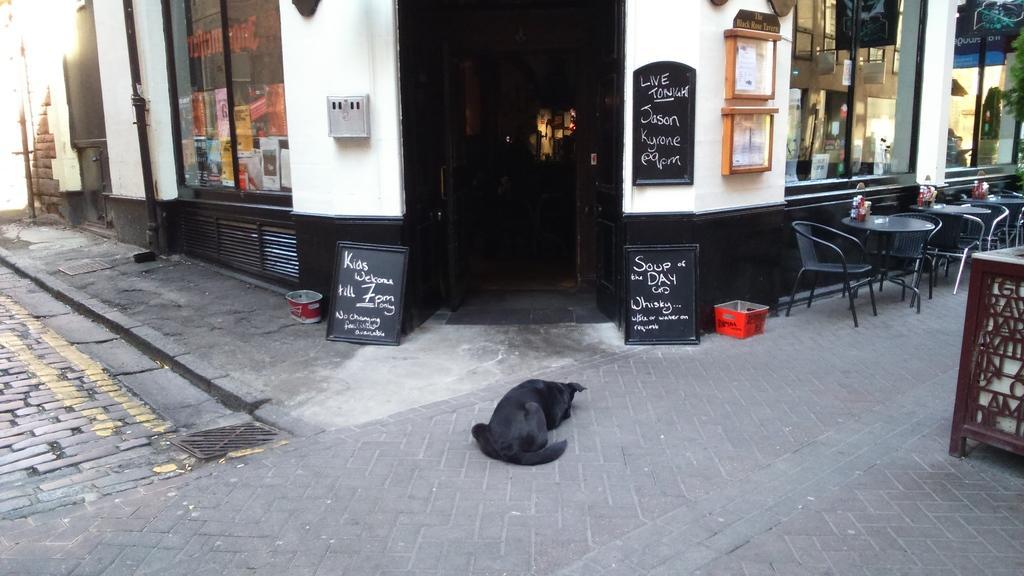In one or two sentences, can you explain what this image depicts? In the image there is a black dog laying on the street and behind there is a building with chairs and tables in front of it, it seems to be a hotel. 